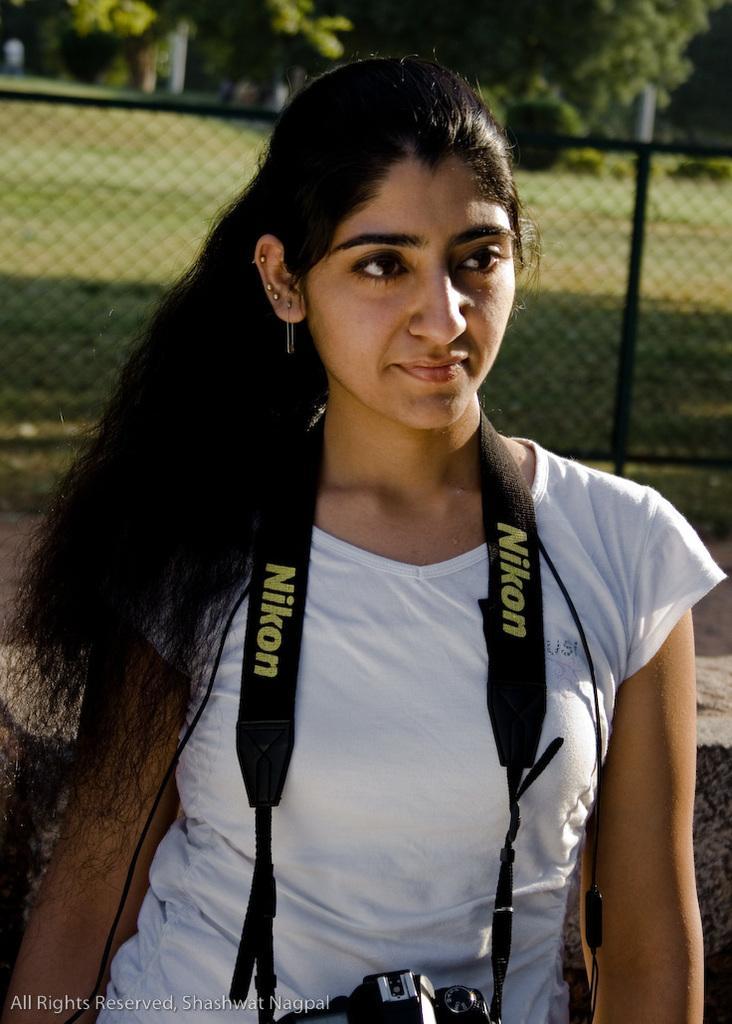Can you describe this image briefly? In this image in the front there is a woman wearing a camera which is black in colour with some text written on it and in the background there is a fence, there's grass on the ground and there are trees. 